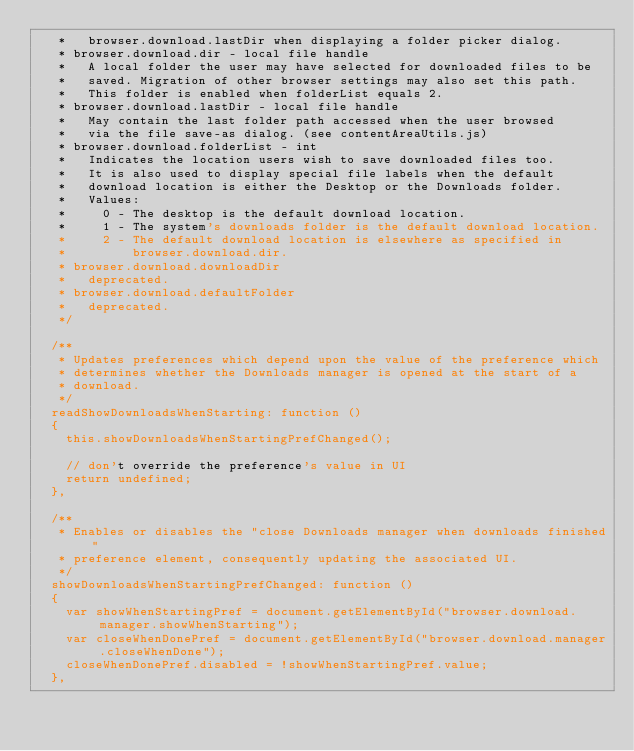<code> <loc_0><loc_0><loc_500><loc_500><_JavaScript_>   *   browser.download.lastDir when displaying a folder picker dialog.
   * browser.download.dir - local file handle
   *   A local folder the user may have selected for downloaded files to be
   *   saved. Migration of other browser settings may also set this path.
   *   This folder is enabled when folderList equals 2.
   * browser.download.lastDir - local file handle
   *   May contain the last folder path accessed when the user browsed
   *   via the file save-as dialog. (see contentAreaUtils.js)
   * browser.download.folderList - int
   *   Indicates the location users wish to save downloaded files too.
   *   It is also used to display special file labels when the default
   *   download location is either the Desktop or the Downloads folder.
   *   Values:
   *     0 - The desktop is the default download location.
   *     1 - The system's downloads folder is the default download location.
   *     2 - The default download location is elsewhere as specified in
   *         browser.download.dir.
   * browser.download.downloadDir
   *   deprecated.
   * browser.download.defaultFolder
   *   deprecated.
   */

  /**
   * Updates preferences which depend upon the value of the preference which
   * determines whether the Downloads manager is opened at the start of a
   * download.
   */
  readShowDownloadsWhenStarting: function ()
  {
    this.showDownloadsWhenStartingPrefChanged();

    // don't override the preference's value in UI
    return undefined;
  },

  /**
   * Enables or disables the "close Downloads manager when downloads finished"
   * preference element, consequently updating the associated UI.
   */
  showDownloadsWhenStartingPrefChanged: function ()
  {
    var showWhenStartingPref = document.getElementById("browser.download.manager.showWhenStarting");
    var closeWhenDonePref = document.getElementById("browser.download.manager.closeWhenDone");
    closeWhenDonePref.disabled = !showWhenStartingPref.value;
  },
</code> 